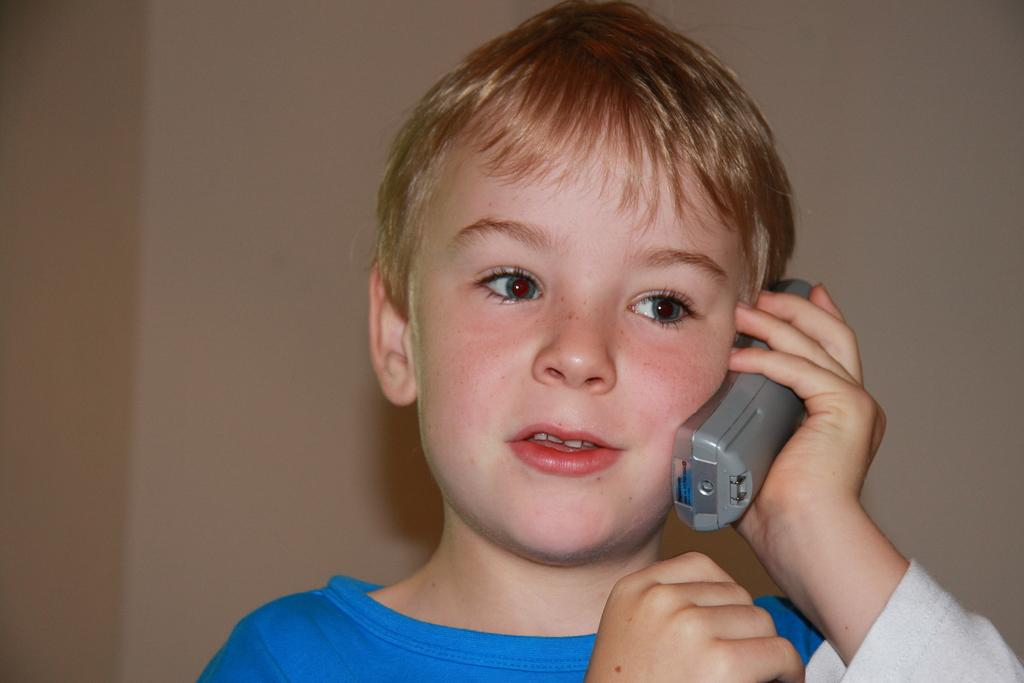Who is the main subject in the image? There is a boy in the image. What is the boy holding in the image? The boy is holding an object that looks like a mobile phone. What can be seen in the background of the image? There is a wall in the background of the image. Where is the bag of crackers placed in the image? There is no bag of crackers present in the image. 